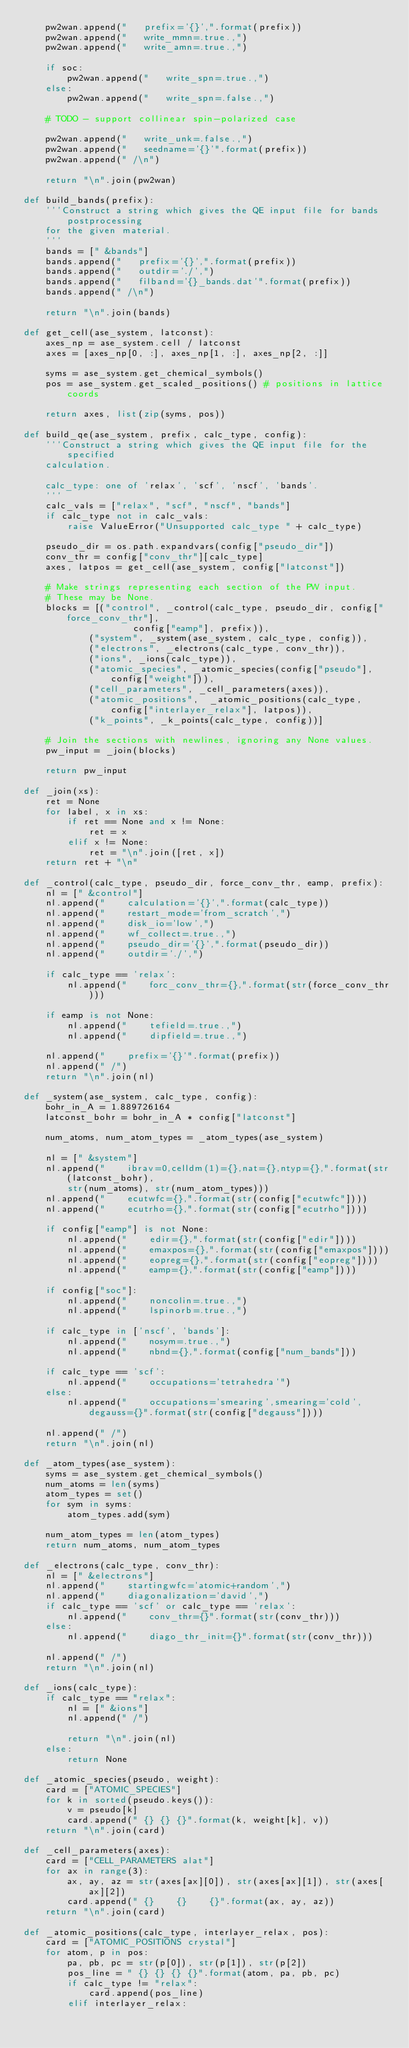<code> <loc_0><loc_0><loc_500><loc_500><_Python_>    pw2wan.append("   prefix='{}',".format(prefix))
    pw2wan.append("   write_mmn=.true.,")
    pw2wan.append("   write_amn=.true.,")

    if soc:
        pw2wan.append("   write_spn=.true.,")
    else:
        pw2wan.append("   write_spn=.false.,")

    # TODO - support collinear spin-polarized case

    pw2wan.append("   write_unk=.false.,")
    pw2wan.append("   seedname='{}'".format(prefix))
    pw2wan.append(" /\n")

    return "\n".join(pw2wan)

def build_bands(prefix):
    '''Construct a string which gives the QE input file for bands postprocessing
    for the given material.
    '''
    bands = [" &bands"]
    bands.append("   prefix='{}',".format(prefix))
    bands.append("   outdir='./',")
    bands.append("   filband='{}_bands.dat'".format(prefix))
    bands.append(" /\n")

    return "\n".join(bands)

def get_cell(ase_system, latconst):
    axes_np = ase_system.cell / latconst
    axes = [axes_np[0, :], axes_np[1, :], axes_np[2, :]]

    syms = ase_system.get_chemical_symbols()
    pos = ase_system.get_scaled_positions() # positions in lattice coords
    
    return axes, list(zip(syms, pos))

def build_qe(ase_system, prefix, calc_type, config):
    '''Construct a string which gives the QE input file for the specified
    calculation.

    calc_type: one of 'relax', 'scf', 'nscf', 'bands'.
    '''
    calc_vals = ["relax", "scf", "nscf", "bands"]
    if calc_type not in calc_vals:
        raise ValueError("Unsupported calc_type " + calc_type)

    pseudo_dir = os.path.expandvars(config["pseudo_dir"])
    conv_thr = config["conv_thr"][calc_type]
    axes, latpos = get_cell(ase_system, config["latconst"])

    # Make strings representing each section of the PW input.
    # These may be None.
    blocks = [("control", _control(calc_type, pseudo_dir, config["force_conv_thr"],
                    config["eamp"], prefix)),
            ("system", _system(ase_system, calc_type, config)),
            ("electrons", _electrons(calc_type, conv_thr)),
            ("ions", _ions(calc_type)),
            ("atomic_species", _atomic_species(config["pseudo"], config["weight"])),
            ("cell_parameters", _cell_parameters(axes)),
            ("atomic_positions",  _atomic_positions(calc_type, config["interlayer_relax"], latpos)),
            ("k_points", _k_points(calc_type, config))]

    # Join the sections with newlines, ignoring any None values.
    pw_input = _join(blocks)

    return pw_input

def _join(xs):
    ret = None
    for label, x in xs:
        if ret == None and x != None:
            ret = x
        elif x != None:
            ret = "\n".join([ret, x])
    return ret + "\n"

def _control(calc_type, pseudo_dir, force_conv_thr, eamp, prefix):
    nl = [" &control"]
    nl.append("    calculation='{}',".format(calc_type))
    nl.append("    restart_mode='from_scratch',")
    nl.append("    disk_io='low',")
    nl.append("    wf_collect=.true.,")
    nl.append("    pseudo_dir='{}',".format(pseudo_dir))
    nl.append("    outdir='./',")

    if calc_type == 'relax':
        nl.append("    forc_conv_thr={},".format(str(force_conv_thr)))

    if eamp is not None:
        nl.append("    tefield=.true.,")
        nl.append("    dipfield=.true.,")

    nl.append("    prefix='{}'".format(prefix))
    nl.append(" /")
    return "\n".join(nl)

def _system(ase_system, calc_type, config):
    bohr_in_A = 1.889726164
    latconst_bohr = bohr_in_A * config["latconst"]

    num_atoms, num_atom_types = _atom_types(ase_system)

    nl = [" &system"]
    nl.append("    ibrav=0,celldm(1)={},nat={},ntyp={},".format(str(latconst_bohr),
        str(num_atoms), str(num_atom_types)))
    nl.append("    ecutwfc={},".format(str(config["ecutwfc"])))
    nl.append("    ecutrho={},".format(str(config["ecutrho"])))

    if config["eamp"] is not None:
        nl.append("    edir={},".format(str(config["edir"])))
        nl.append("    emaxpos={},".format(str(config["emaxpos"])))
        nl.append("    eopreg={},".format(str(config["eopreg"])))
        nl.append("    eamp={},".format(str(config["eamp"])))

    if config["soc"]:
        nl.append("    noncolin=.true.,")
        nl.append("    lspinorb=.true.,")

    if calc_type in ['nscf', 'bands']:
        nl.append("    nosym=.true.,")
        nl.append("    nbnd={},".format(config["num_bands"]))

    if calc_type == 'scf':
        nl.append("    occupations='tetrahedra'")
    else:
        nl.append("    occupations='smearing',smearing='cold',degauss={}".format(str(config["degauss"])))

    nl.append(" /")    
    return "\n".join(nl)

def _atom_types(ase_system):
    syms = ase_system.get_chemical_symbols()
    num_atoms = len(syms)
    atom_types = set()
    for sym in syms:
        atom_types.add(sym)

    num_atom_types = len(atom_types)
    return num_atoms, num_atom_types

def _electrons(calc_type, conv_thr):
    nl = [" &electrons"]
    nl.append("    startingwfc='atomic+random',")
    nl.append("    diagonalization='david',")
    if calc_type == 'scf' or calc_type == 'relax':
        nl.append("    conv_thr={}".format(str(conv_thr)))
    else:
        nl.append("    diago_thr_init={}".format(str(conv_thr)))

    nl.append(" /")
    return "\n".join(nl)

def _ions(calc_type):
    if calc_type == "relax":
        nl = [" &ions"]
        nl.append(" /")

        return "\n".join(nl)
    else:
        return None

def _atomic_species(pseudo, weight):
    card = ["ATOMIC_SPECIES"]
    for k in sorted(pseudo.keys()):
        v = pseudo[k]
        card.append(" {} {} {}".format(k, weight[k], v))
    return "\n".join(card)

def _cell_parameters(axes):
    card = ["CELL_PARAMETERS alat"]
    for ax in range(3):
        ax, ay, az = str(axes[ax][0]), str(axes[ax][1]), str(axes[ax][2])
        card.append(" {}    {}    {}".format(ax, ay, az))
    return "\n".join(card)

def _atomic_positions(calc_type, interlayer_relax, pos):
    card = ["ATOMIC_POSITIONS crystal"]
    for atom, p in pos:
        pa, pb, pc = str(p[0]), str(p[1]), str(p[2])
        pos_line = " {} {} {} {}".format(atom, pa, pb, pc)
        if calc_type != "relax":
            card.append(pos_line)
        elif interlayer_relax:</code> 